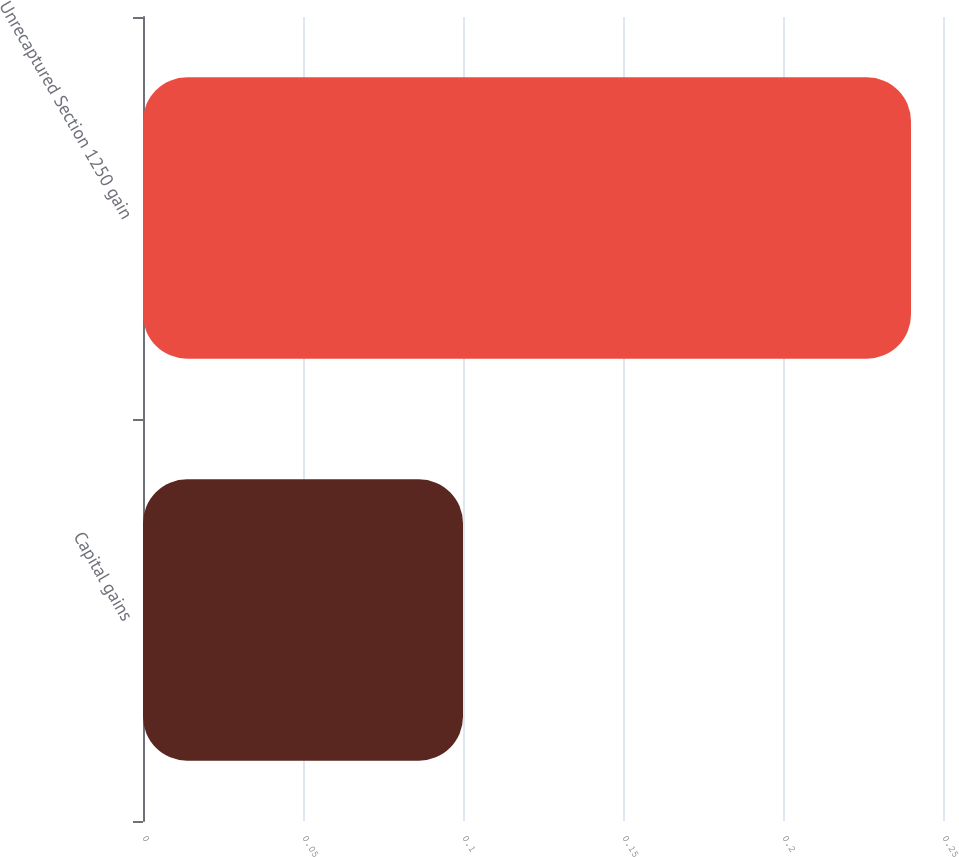Convert chart to OTSL. <chart><loc_0><loc_0><loc_500><loc_500><bar_chart><fcel>Capital gains<fcel>Unrecaptured Section 1250 gain<nl><fcel>0.1<fcel>0.24<nl></chart> 